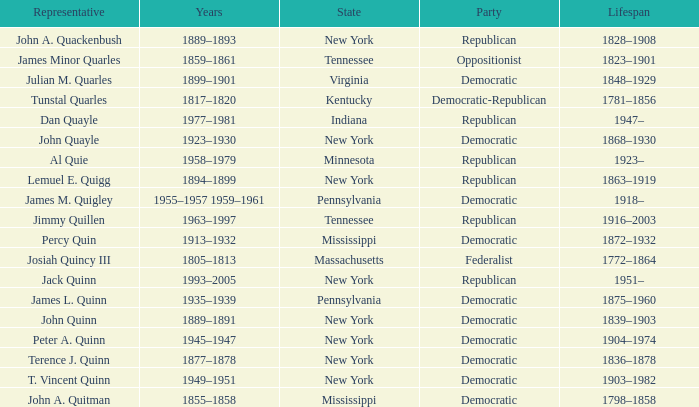For how long has the democratic party been active in new york, with terence j. quinn as one of its representatives? 1836–1878. 